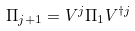<formula> <loc_0><loc_0><loc_500><loc_500>\Pi _ { j + 1 } = V ^ { j } \Pi _ { 1 } V ^ { \dag j }</formula> 